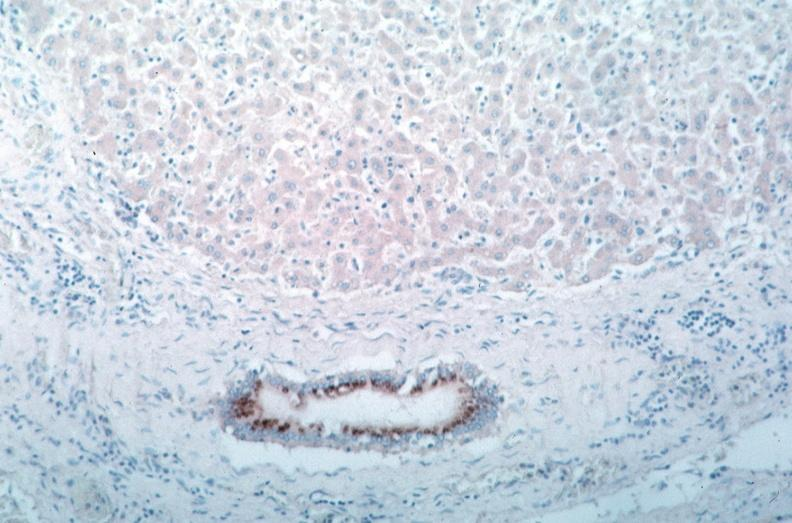what is vasculitis , rocky mountain spotted?
Answer the question using a single word or phrase. Fever immunoperoxidase staining vessels for rickettsia rickettsii 